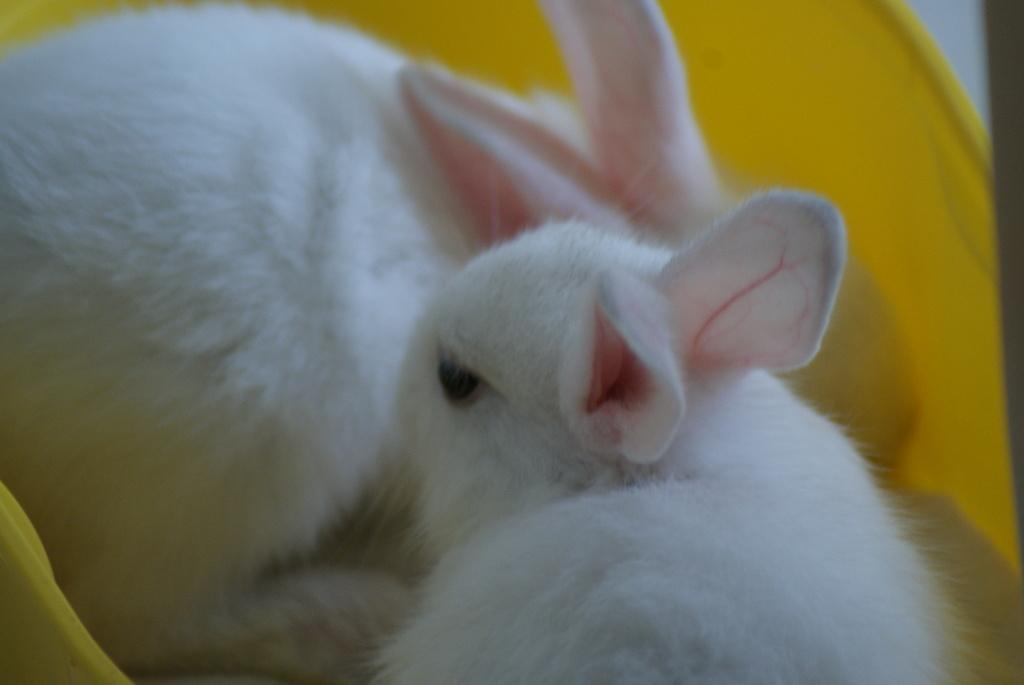What is the color of the object in the image? The object in the image is yellow. What is inside the yellow object? The yellow object contains two rabbits. What colors are the rabbits? The rabbits are white, black, and pink in color. What type of tin can be seen in the image? There is no tin present in the image. What statement does the rabbit make in the image? The image does not depict any rabbits making a statement, as it is a still image. 